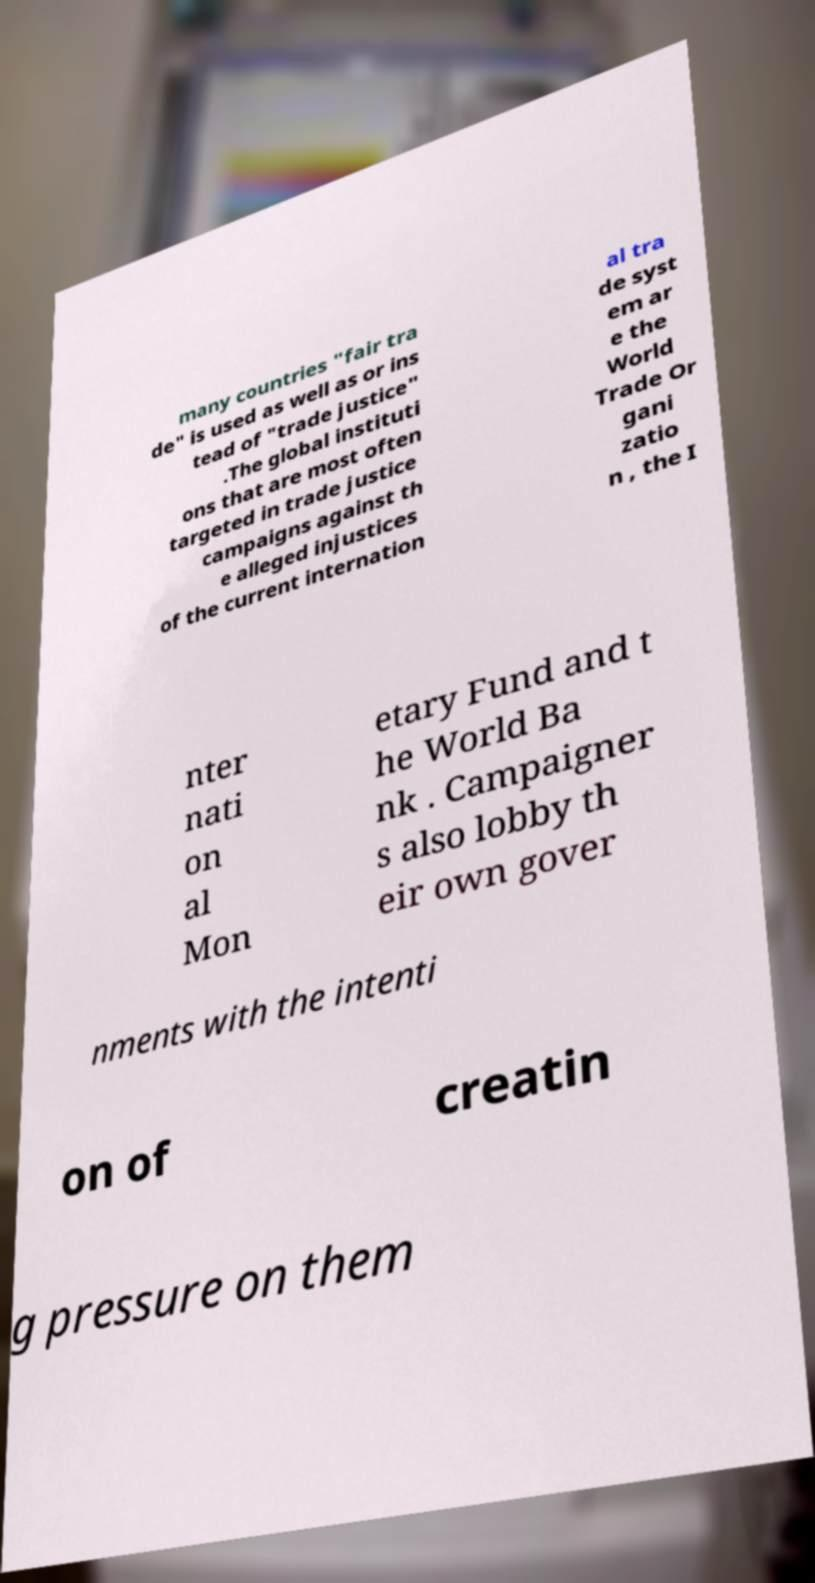Could you extract and type out the text from this image? many countries "fair tra de" is used as well as or ins tead of "trade justice" .The global instituti ons that are most often targeted in trade justice campaigns against th e alleged injustices of the current internation al tra de syst em ar e the World Trade Or gani zatio n , the I nter nati on al Mon etary Fund and t he World Ba nk . Campaigner s also lobby th eir own gover nments with the intenti on of creatin g pressure on them 